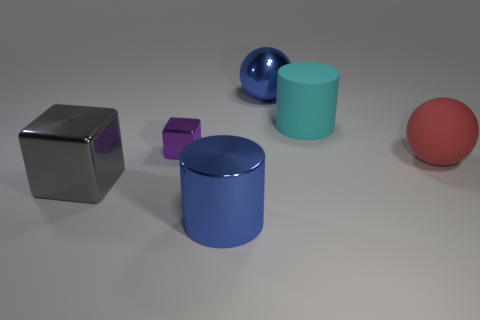Is the size of the metallic cylinder the same as the ball that is on the right side of the blue ball?
Keep it short and to the point. Yes. What is the material of the sphere that is behind the tiny object?
Your answer should be very brief. Metal. What number of large objects are behind the big metallic cylinder and on the right side of the large gray metallic cube?
Your response must be concise. 3. There is a red thing that is the same size as the blue metal cylinder; what material is it?
Ensure brevity in your answer.  Rubber. There is a sphere that is in front of the purple shiny object; is its size the same as the metal cube that is on the right side of the gray thing?
Keep it short and to the point. No. There is a small purple metal object; are there any shiny balls right of it?
Your response must be concise. Yes. There is a large ball that is on the right side of the large blue shiny thing behind the gray object; what is its color?
Give a very brief answer. Red. Are there fewer large shiny balls than big things?
Provide a succinct answer. Yes. What number of other tiny gray metal objects have the same shape as the gray shiny object?
Ensure brevity in your answer.  0. What is the color of the matte cylinder that is the same size as the metal cylinder?
Make the answer very short. Cyan. 